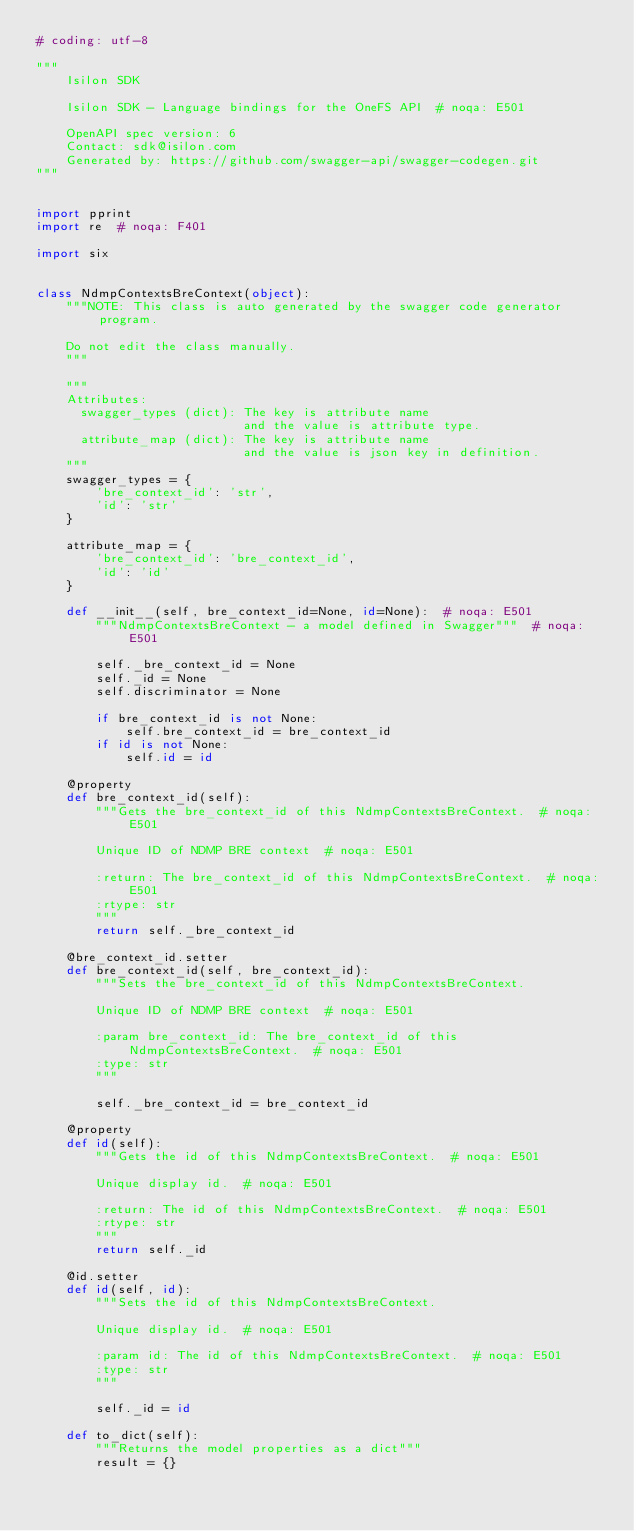<code> <loc_0><loc_0><loc_500><loc_500><_Python_># coding: utf-8

"""
    Isilon SDK

    Isilon SDK - Language bindings for the OneFS API  # noqa: E501

    OpenAPI spec version: 6
    Contact: sdk@isilon.com
    Generated by: https://github.com/swagger-api/swagger-codegen.git
"""


import pprint
import re  # noqa: F401

import six


class NdmpContextsBreContext(object):
    """NOTE: This class is auto generated by the swagger code generator program.

    Do not edit the class manually.
    """

    """
    Attributes:
      swagger_types (dict): The key is attribute name
                            and the value is attribute type.
      attribute_map (dict): The key is attribute name
                            and the value is json key in definition.
    """
    swagger_types = {
        'bre_context_id': 'str',
        'id': 'str'
    }

    attribute_map = {
        'bre_context_id': 'bre_context_id',
        'id': 'id'
    }

    def __init__(self, bre_context_id=None, id=None):  # noqa: E501
        """NdmpContextsBreContext - a model defined in Swagger"""  # noqa: E501

        self._bre_context_id = None
        self._id = None
        self.discriminator = None

        if bre_context_id is not None:
            self.bre_context_id = bre_context_id
        if id is not None:
            self.id = id

    @property
    def bre_context_id(self):
        """Gets the bre_context_id of this NdmpContextsBreContext.  # noqa: E501

        Unique ID of NDMP BRE context  # noqa: E501

        :return: The bre_context_id of this NdmpContextsBreContext.  # noqa: E501
        :rtype: str
        """
        return self._bre_context_id

    @bre_context_id.setter
    def bre_context_id(self, bre_context_id):
        """Sets the bre_context_id of this NdmpContextsBreContext.

        Unique ID of NDMP BRE context  # noqa: E501

        :param bre_context_id: The bre_context_id of this NdmpContextsBreContext.  # noqa: E501
        :type: str
        """

        self._bre_context_id = bre_context_id

    @property
    def id(self):
        """Gets the id of this NdmpContextsBreContext.  # noqa: E501

        Unique display id.  # noqa: E501

        :return: The id of this NdmpContextsBreContext.  # noqa: E501
        :rtype: str
        """
        return self._id

    @id.setter
    def id(self, id):
        """Sets the id of this NdmpContextsBreContext.

        Unique display id.  # noqa: E501

        :param id: The id of this NdmpContextsBreContext.  # noqa: E501
        :type: str
        """

        self._id = id

    def to_dict(self):
        """Returns the model properties as a dict"""
        result = {}
</code> 